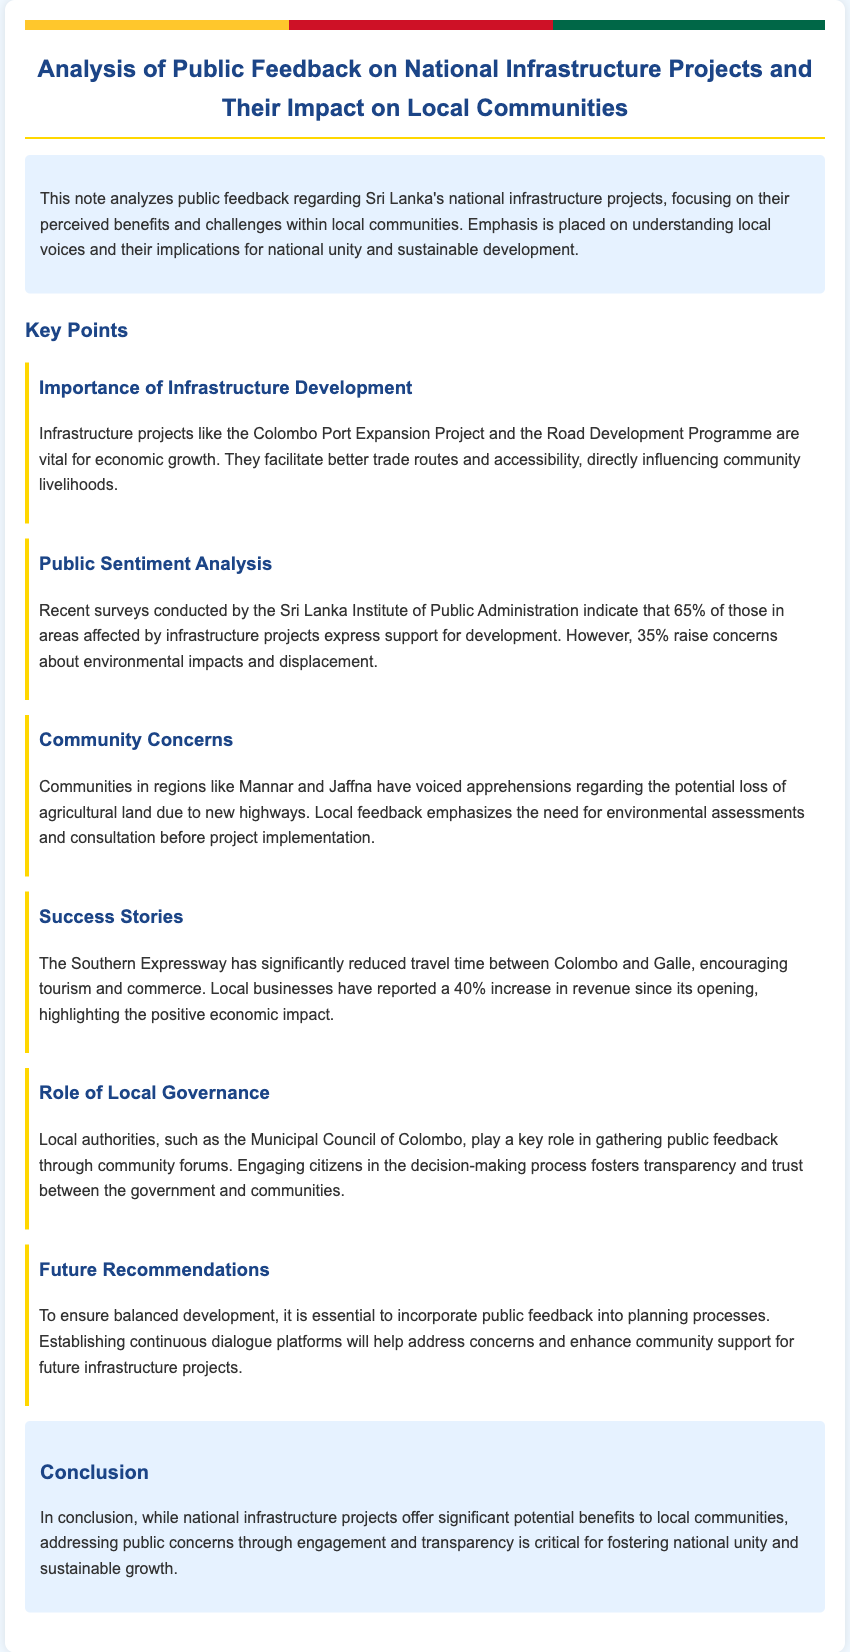What is the main focus of this note? The main focus of the note is to analyze public feedback regarding Sri Lanka's national infrastructure projects, especially their perceived benefits and challenges within local communities.
Answer: public feedback on national infrastructure projects What percentage of the surveyed population supports infrastructure development? The note indicates that 65% of those in affected areas express support for development.
Answer: 65% Which regions have voiced concerns about agricultural land loss? The communities in Mannar and Jaffna have expressed apprehensions about potential agricultural land loss.
Answer: Mannar and Jaffna What is the reported percentage increase in local business revenue since the Southern Expressway opened? The document states that local businesses have reported a 40% increase in revenue since the Southern Expressway's opening.
Answer: 40% What role do local authorities play in public feedback? Local authorities, such as the Municipal Council of Colombo, are responsible for gathering public feedback through community forums.
Answer: gathering public feedback What does the conclusion suggest is critical for fostering national unity? The conclusion emphasizes that addressing public concerns through engagement and transparency is critical for fostering national unity and sustainable growth.
Answer: engagement and transparency 